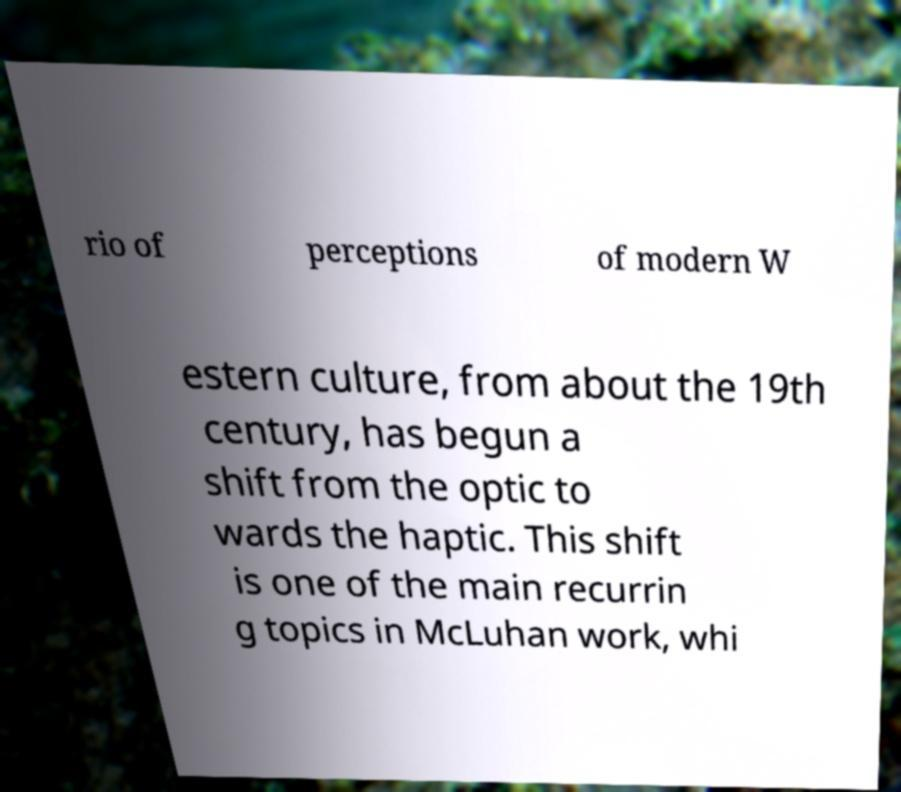I need the written content from this picture converted into text. Can you do that? rio of perceptions of modern W estern culture, from about the 19th century, has begun a shift from the optic to wards the haptic. This shift is one of the main recurrin g topics in McLuhan work, whi 